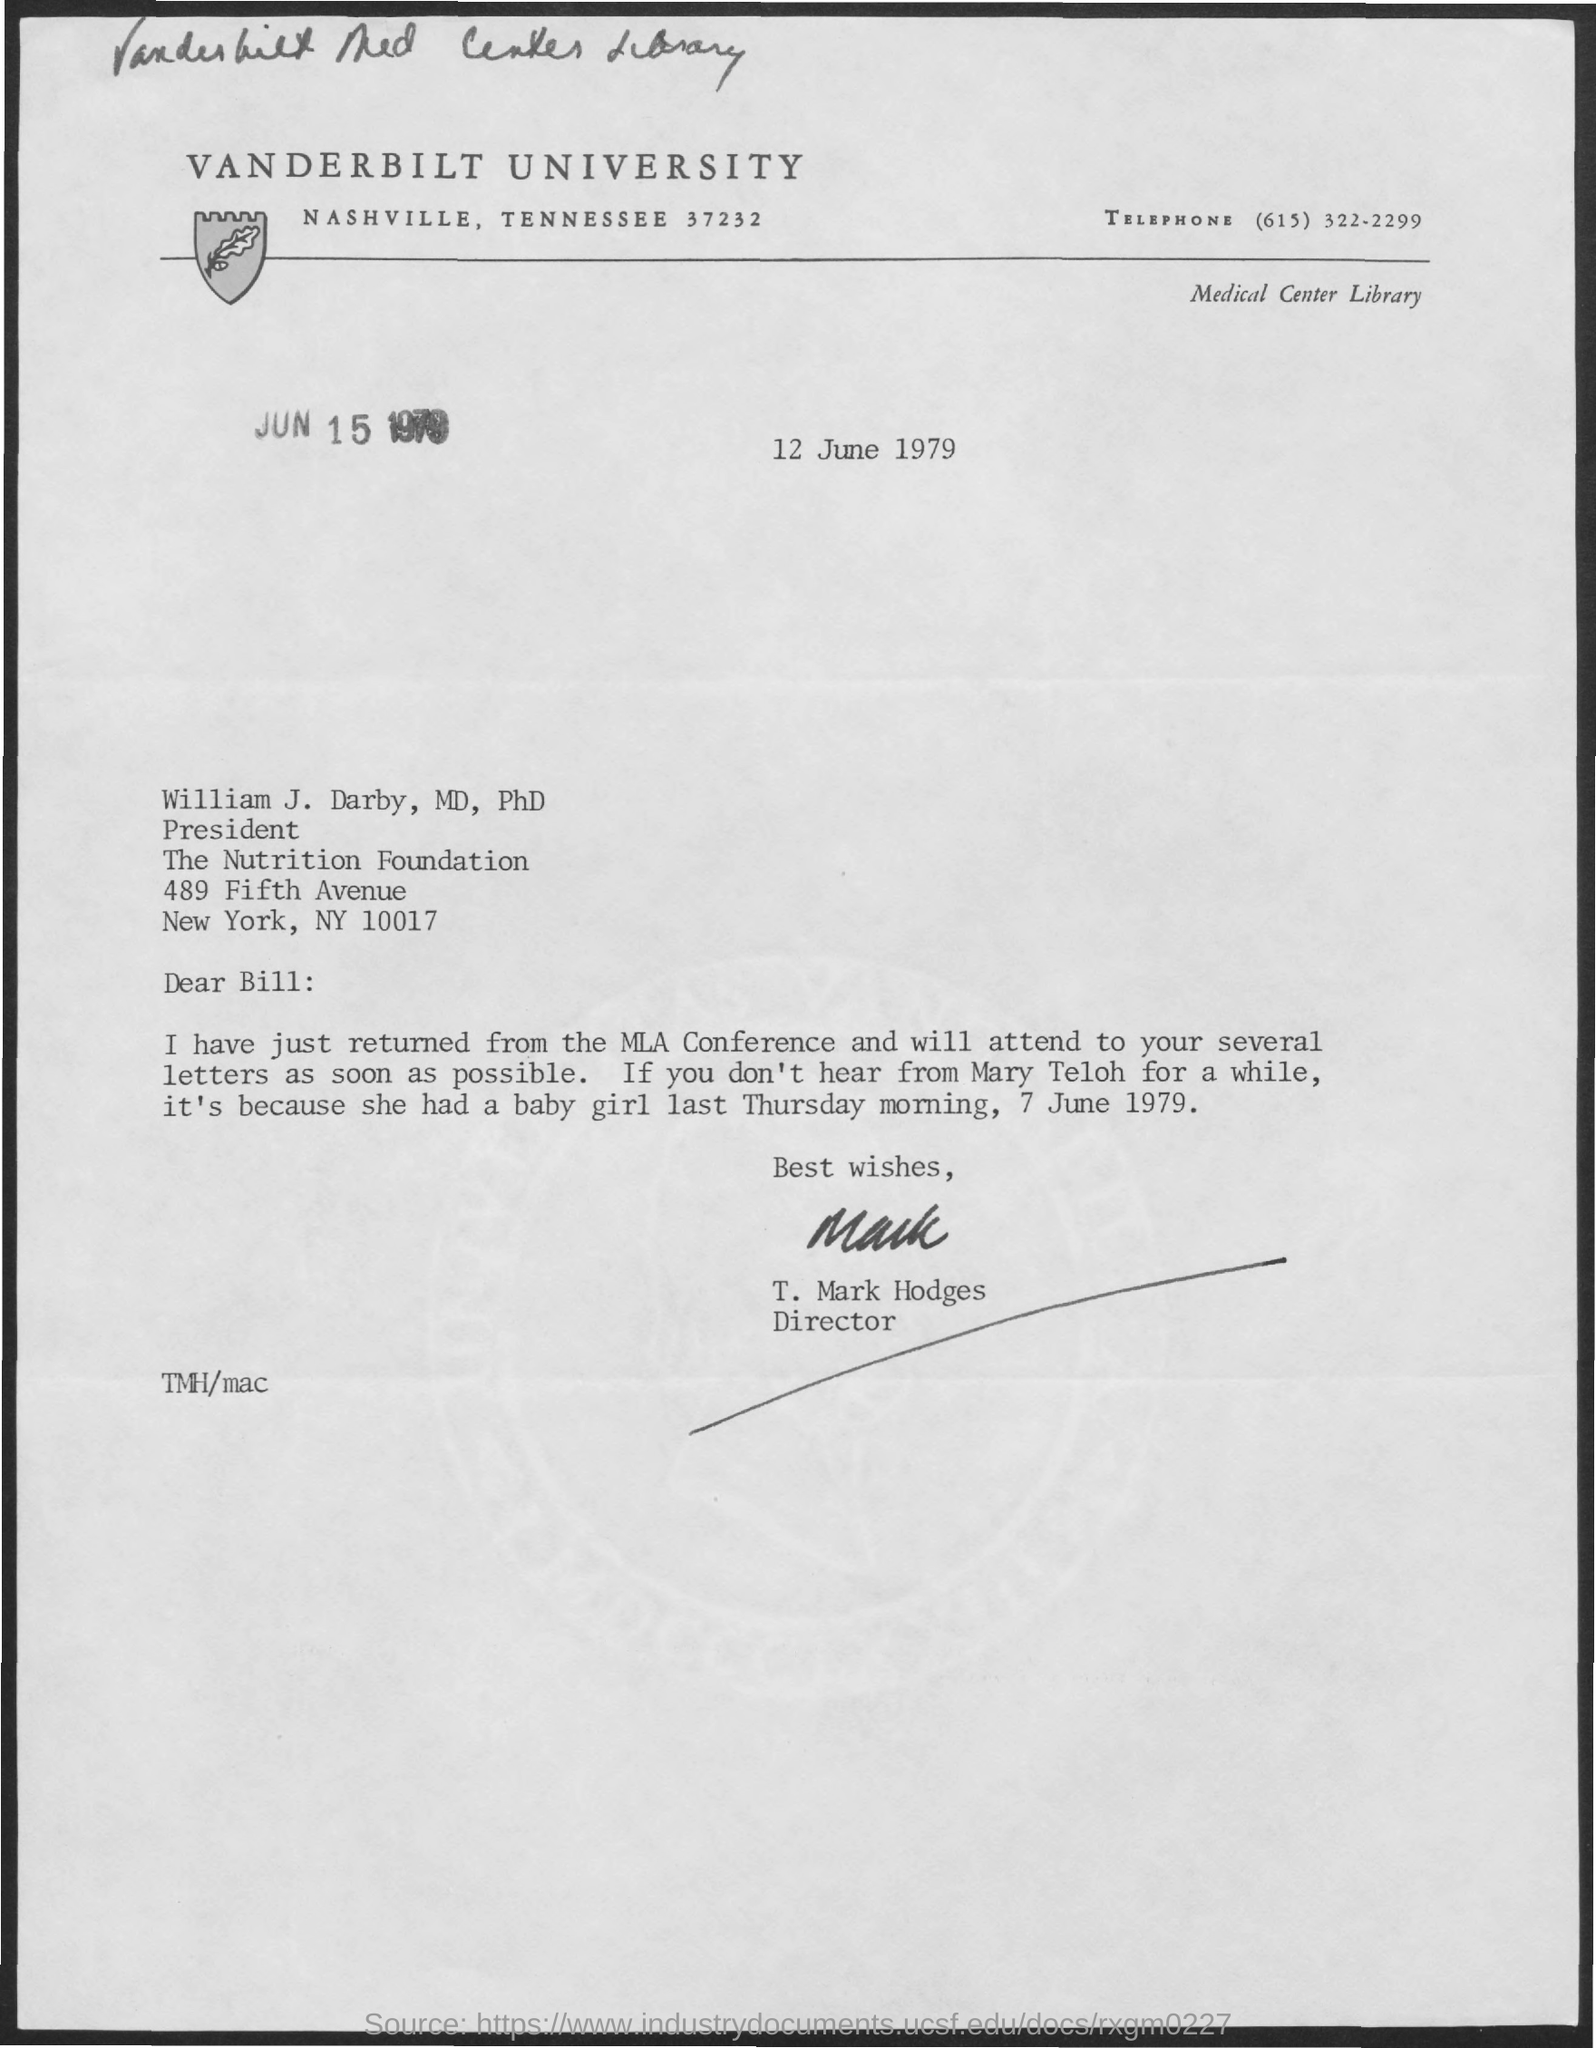What is the name of the university mentioned in the given form ?
Provide a succinct answer. Vanderbilt university. What is the telephone no. mentioned in the given page ?
Provide a succinct answer. (615) 322-2299. What is the designation of william j darby mentioned ?
Provide a succinct answer. President. To whom the letter was sent ?
Ensure brevity in your answer.  William J. Darby, MD, PhD. Who's sign was there at the bottom of the letter ?
Give a very brief answer. T. Mark Hodges. What is the designation of t.mark hodges ?
Offer a terse response. Director. 